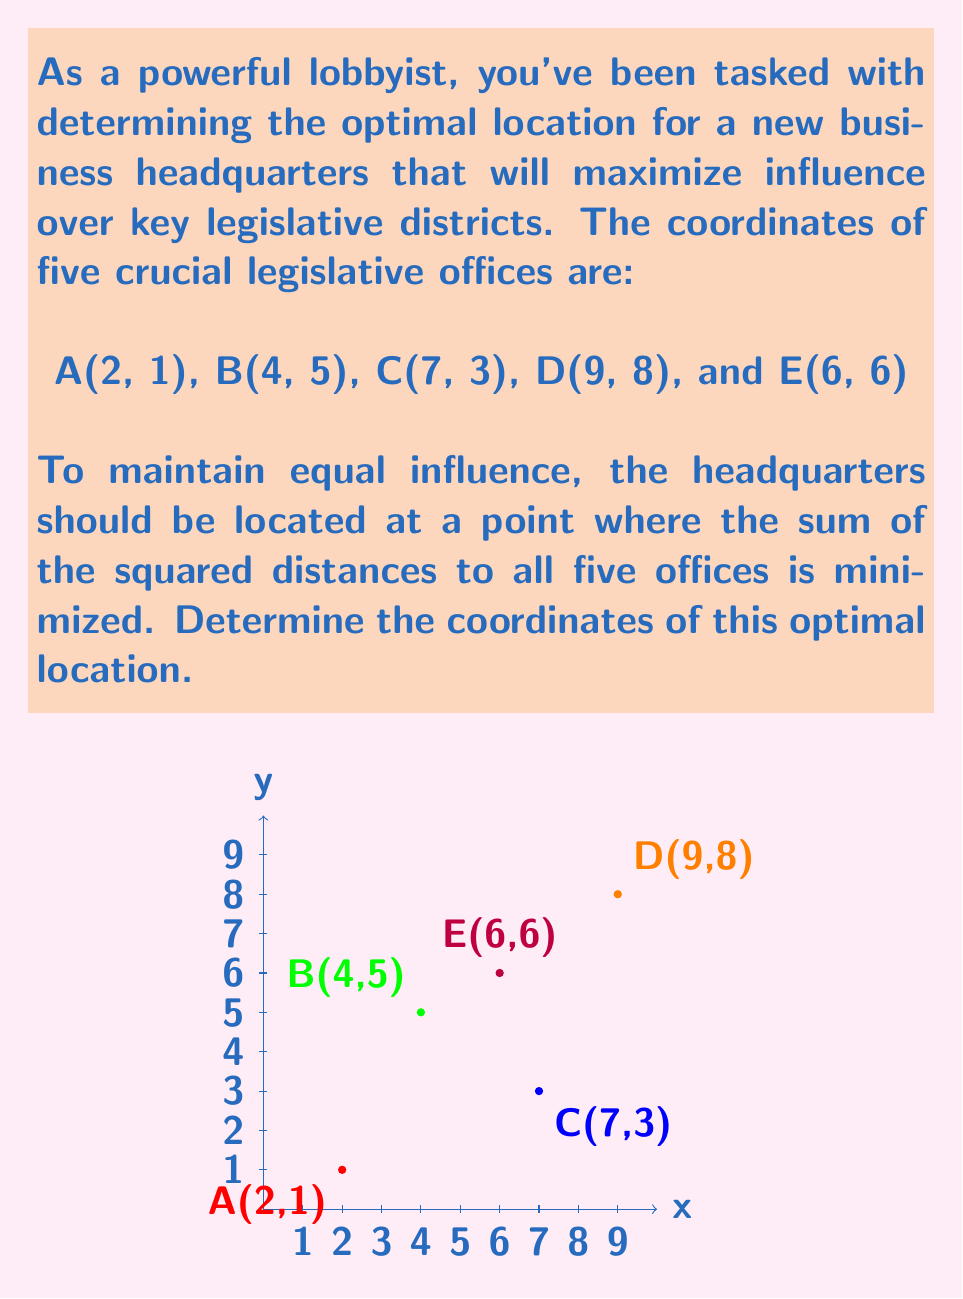Provide a solution to this math problem. To find the optimal location, we need to use the concept of the centroid of a system of points. The centroid minimizes the sum of squared distances to all points in the system.

Step 1: Calculate the x-coordinate of the centroid.
The x-coordinate is the average of all x-coordinates:
$$x = \frac{2 + 4 + 7 + 9 + 6}{5} = \frac{28}{5} = 5.6$$

Step 2: Calculate the y-coordinate of the centroid.
The y-coordinate is the average of all y-coordinates:
$$y = \frac{1 + 5 + 3 + 8 + 6}{5} = \frac{23}{5} = 4.6$$

Step 3: Verify that this point minimizes the sum of squared distances.
The formula for the sum of squared distances from a point $(x,y)$ to a set of points $(x_i, y_i)$ is:

$$\sum_{i=1}^n [(x-x_i)^2 + (y-y_i)^2]$$

The partial derivatives of this sum with respect to x and y, when set to zero, yield the centroid coordinates as the solution.

Therefore, the point (5.6, 4.6) is indeed the optimal location for the headquarters.
Answer: (5.6, 4.6) 